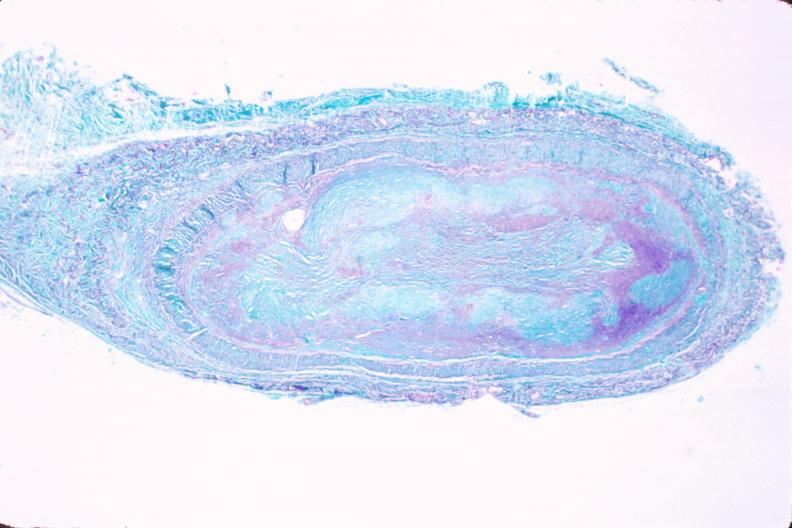what is present?
Answer the question using a single word or phrase. Cardiovascular 